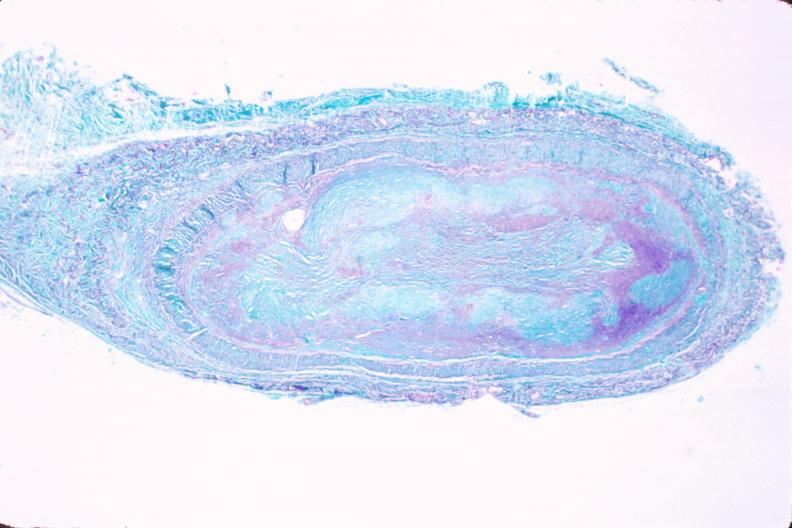what is present?
Answer the question using a single word or phrase. Cardiovascular 